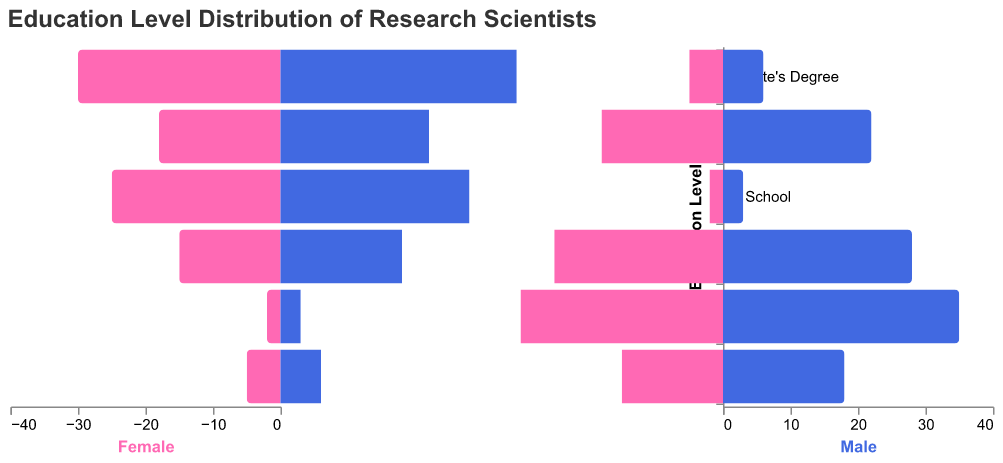What is the title of the figure? The title of the figure is located at the top and is a text element. It reads "Education Level Distribution of Research Scientists".
Answer: Education Level Distribution of Research Scientists How many education levels are displayed in the figure? By counting the distinct bars or labels along the "Education Level" axis, we can see there are six distinct education levels displayed in the figure.
Answer: Six What is the education level with the highest number of male research scientists? By observing the length of the bars for the male category (in blue), the education level with the highest value is "Ph.D.".
Answer: Ph.D Which gender has more Postdoctoral research scientists? By comparing the lengths of the bars for "Postdoctoral" level, the male bar is longer than the female bar.
Answer: Male How many female scientists have a Master's Degree? The female bar for "Master's Degree" has a numerical value, which is 25, indicated on the horizontal axis.
Answer: 25 How many more male scientists hold a Bachelor's Degree compared to females? The difference between the male and female values for "Bachelor's Degree" is calculated as 22 (male) - 18 (female).
Answer: 4 What is the total number of research scientists with a Ph.D.? To get the total, add the number of female and male scientists with a Ph.D.: 30 (female) + 35 (male) = 65.
Answer: 65 What is the average number of male research scientists across all education levels? Sum the number of male scientists across all levels and divide by the number of levels: (3 + 6 + 22 + 28 + 35 + 18) / 6 = 112 / 6 = approximately 18.67.
Answer: Approximately 18.67 Compare the total number of scientists (both genders) with an Associate's Degree to those with a Postdoctoral level. Which is higher? Calculate the total for each level and compare: Associate's Degree = 5 (female) + 6 (male) = 11, Postdoctoral = 15 (female) + 18 (male) = 33. Postdoctoral has more scientists.
Answer: Postdoctoral 